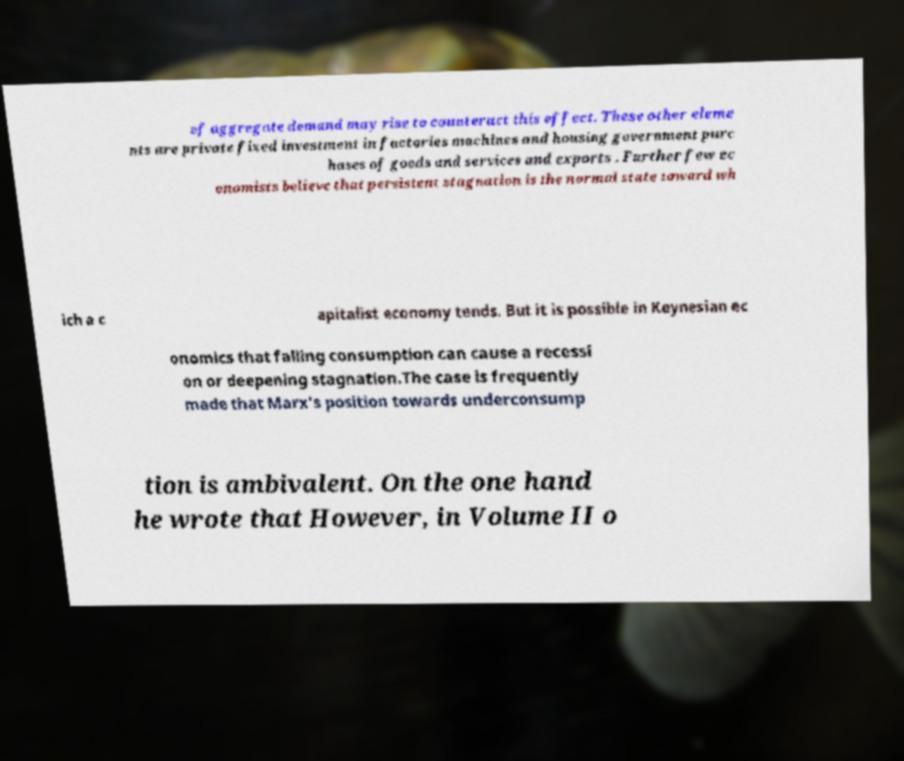I need the written content from this picture converted into text. Can you do that? of aggregate demand may rise to counteract this effect. These other eleme nts are private fixed investment in factories machines and housing government purc hases of goods and services and exports . Further few ec onomists believe that persistent stagnation is the normal state toward wh ich a c apitalist economy tends. But it is possible in Keynesian ec onomics that falling consumption can cause a recessi on or deepening stagnation.The case is frequently made that Marx's position towards underconsump tion is ambivalent. On the one hand he wrote that However, in Volume II o 